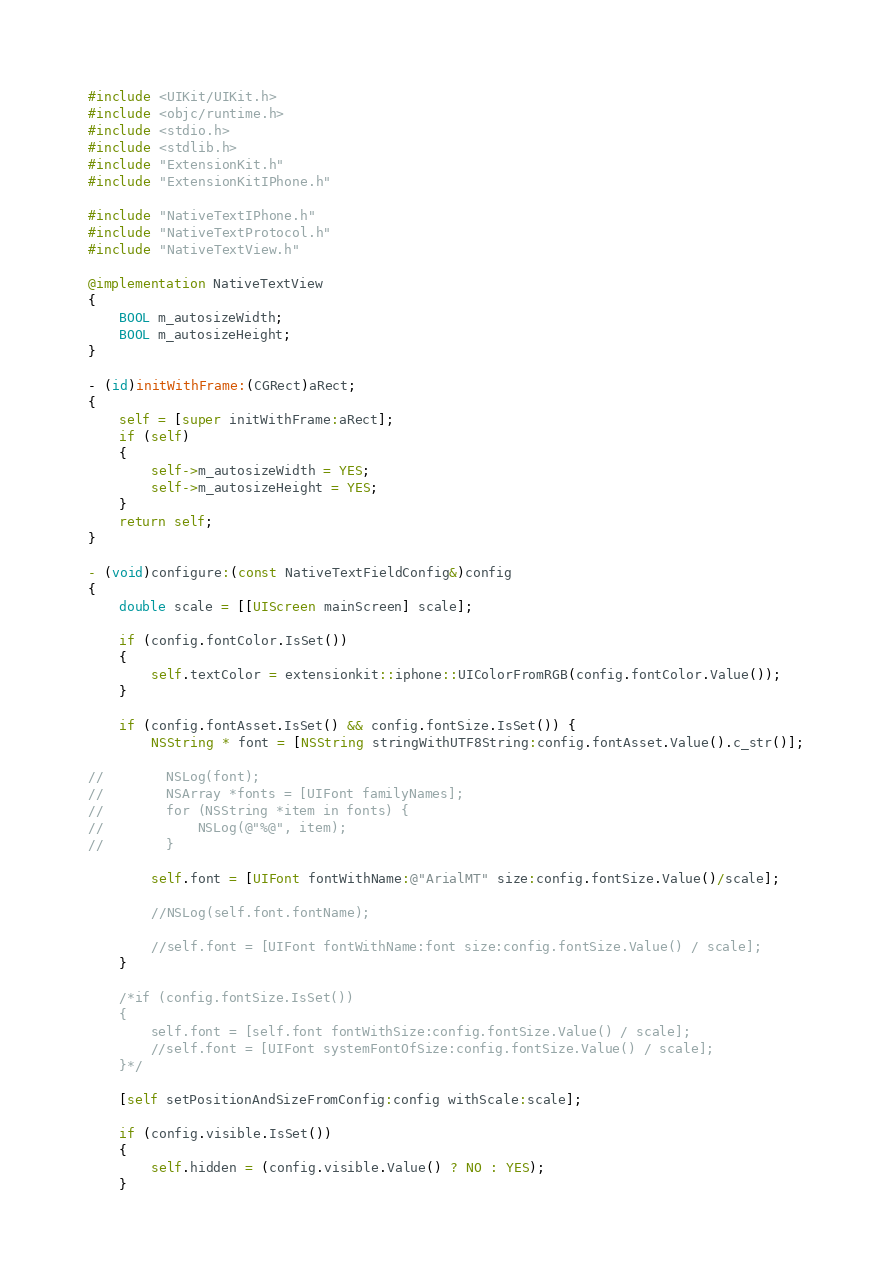<code> <loc_0><loc_0><loc_500><loc_500><_ObjectiveC_>#include <UIKit/UIKit.h>
#include <objc/runtime.h>
#include <stdio.h>
#include <stdlib.h>
#include "ExtensionKit.h"
#include "ExtensionKitIPhone.h"

#include "NativeTextIPhone.h"
#include "NativeTextProtocol.h"
#include "NativeTextView.h"

@implementation NativeTextView
{
    BOOL m_autosizeWidth;
    BOOL m_autosizeHeight;
}

- (id)initWithFrame:(CGRect)aRect;
{
    self = [super initWithFrame:aRect];
    if (self)
    {
        self->m_autosizeWidth = YES;
        self->m_autosizeHeight = YES;
    }
    return self;
}

- (void)configure:(const NativeTextFieldConfig&)config
{
    double scale = [[UIScreen mainScreen] scale];

    if (config.fontColor.IsSet())
    {
        self.textColor = extensionkit::iphone::UIColorFromRGB(config.fontColor.Value());
    }

    if (config.fontAsset.IsSet() && config.fontSize.IsSet()) {
        NSString * font = [NSString stringWithUTF8String:config.fontAsset.Value().c_str()];

//        NSLog(font);
//        NSArray *fonts = [UIFont familyNames];
//        for (NSString *item in fonts) {
//            NSLog(@"%@", item);
//        }

        self.font = [UIFont fontWithName:@"ArialMT" size:config.fontSize.Value()/scale];

        //NSLog(self.font.fontName);

        //self.font = [UIFont fontWithName:font size:config.fontSize.Value() / scale];
    }

    /*if (config.fontSize.IsSet())
    {
        self.font = [self.font fontWithSize:config.fontSize.Value() / scale];
        //self.font = [UIFont systemFontOfSize:config.fontSize.Value() / scale];
    }*/

    [self setPositionAndSizeFromConfig:config withScale:scale];

    if (config.visible.IsSet())
    {
        self.hidden = (config.visible.Value() ? NO : YES);
    }
</code> 